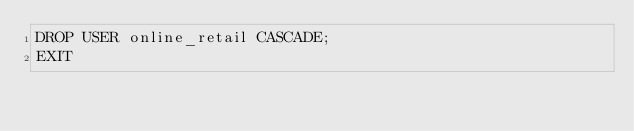<code> <loc_0><loc_0><loc_500><loc_500><_SQL_>DROP USER online_retail CASCADE;
EXIT
</code> 